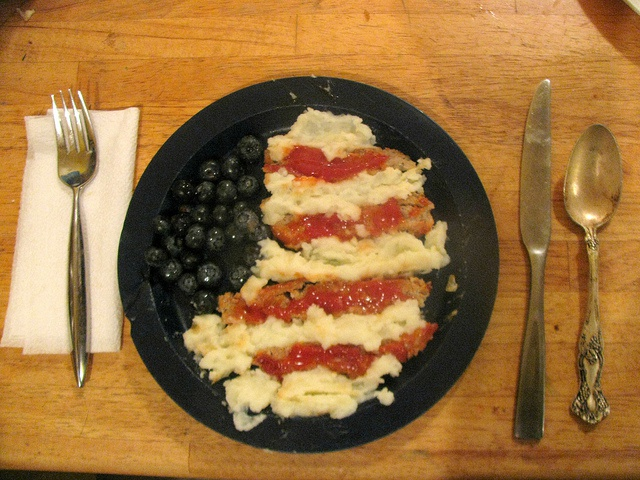Describe the objects in this image and their specific colors. I can see dining table in olive, black, tan, and orange tones, spoon in black, olive, and tan tones, knife in black and olive tones, and fork in black, olive, tan, and gray tones in this image. 